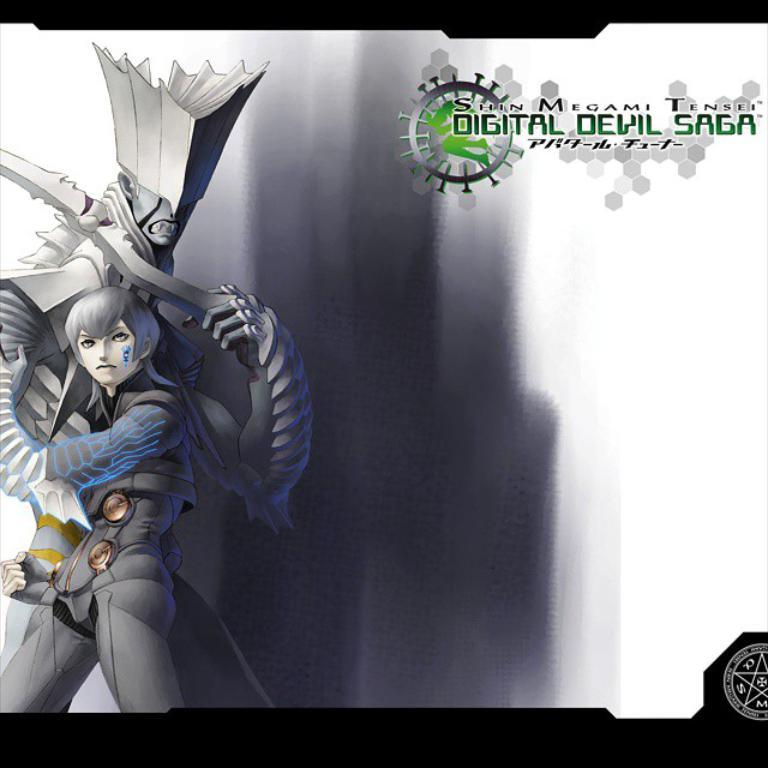What type of image is being described? The image is animated. Can you describe the characters on the left side of the image? There are two persons on the left side of the image. What else can be seen on the image besides the characters? There are texts on the image. How would you describe the background of the image? The background of the image has a combination of ash and white colors. What is the current position of the love in the image? There is no mention of love or any related concept in the image, so it cannot be determined. 